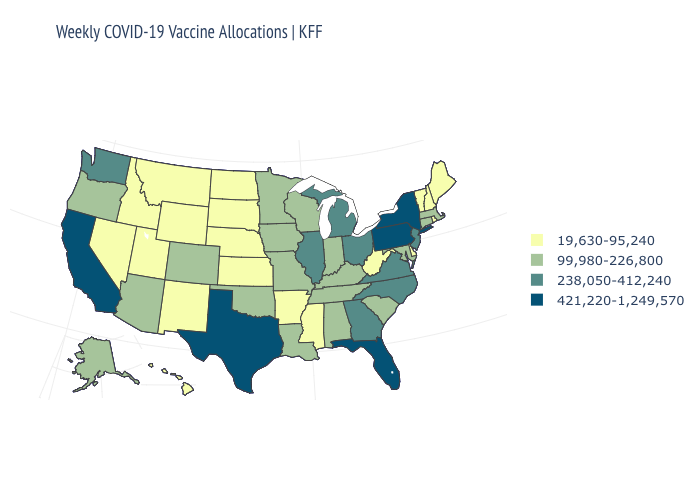What is the value of Washington?
Give a very brief answer. 238,050-412,240. What is the value of North Dakota?
Answer briefly. 19,630-95,240. Name the states that have a value in the range 238,050-412,240?
Write a very short answer. Georgia, Illinois, Michigan, New Jersey, North Carolina, Ohio, Virginia, Washington. Does Ohio have the lowest value in the MidWest?
Be succinct. No. Name the states that have a value in the range 99,980-226,800?
Give a very brief answer. Alabama, Alaska, Arizona, Colorado, Connecticut, Indiana, Iowa, Kentucky, Louisiana, Maryland, Massachusetts, Minnesota, Missouri, Oklahoma, Oregon, South Carolina, Tennessee, Wisconsin. What is the value of Utah?
Write a very short answer. 19,630-95,240. Name the states that have a value in the range 421,220-1,249,570?
Write a very short answer. California, Florida, New York, Pennsylvania, Texas. What is the value of California?
Write a very short answer. 421,220-1,249,570. Does the map have missing data?
Give a very brief answer. No. What is the lowest value in states that border New Hampshire?
Concise answer only. 19,630-95,240. Does the first symbol in the legend represent the smallest category?
Give a very brief answer. Yes. Does Kansas have the highest value in the USA?
Concise answer only. No. What is the highest value in the USA?
Keep it brief. 421,220-1,249,570. Name the states that have a value in the range 19,630-95,240?
Write a very short answer. Arkansas, Delaware, Hawaii, Idaho, Kansas, Maine, Mississippi, Montana, Nebraska, Nevada, New Hampshire, New Mexico, North Dakota, Rhode Island, South Dakota, Utah, Vermont, West Virginia, Wyoming. Among the states that border Wisconsin , does Minnesota have the lowest value?
Be succinct. Yes. 